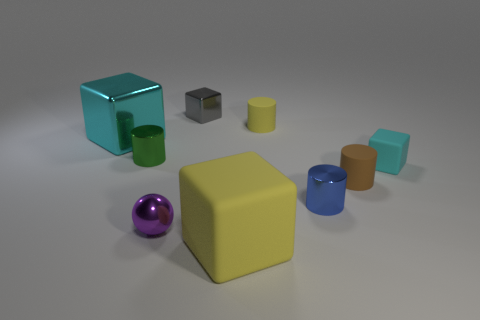Subtract all gray cylinders. Subtract all red blocks. How many cylinders are left? 4 Subtract all blocks. How many objects are left? 5 Add 7 blue cylinders. How many blue cylinders exist? 8 Subtract 0 blue cubes. How many objects are left? 9 Subtract all small cyan rubber objects. Subtract all small green objects. How many objects are left? 7 Add 7 tiny cyan things. How many tiny cyan things are left? 8 